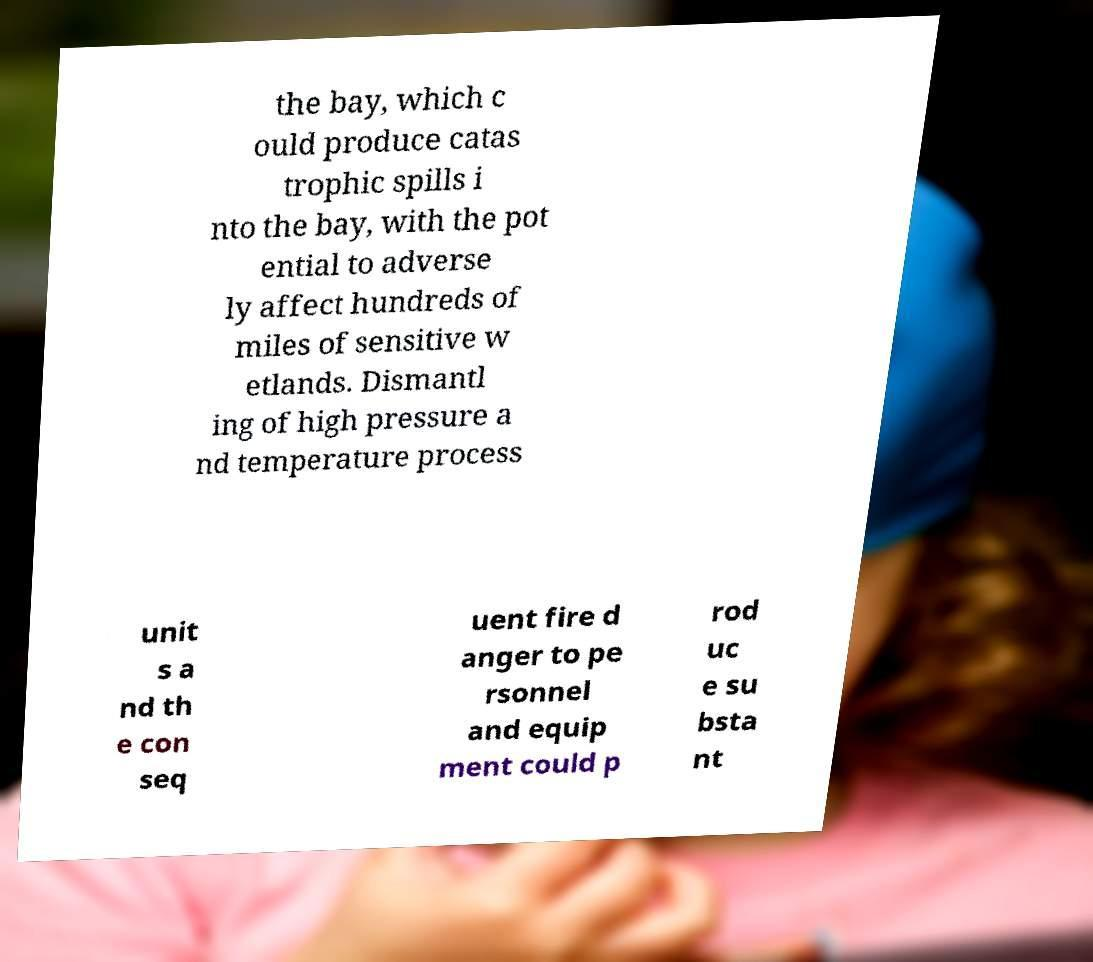Could you extract and type out the text from this image? the bay, which c ould produce catas trophic spills i nto the bay, with the pot ential to adverse ly affect hundreds of miles of sensitive w etlands. Dismantl ing of high pressure a nd temperature process unit s a nd th e con seq uent fire d anger to pe rsonnel and equip ment could p rod uc e su bsta nt 